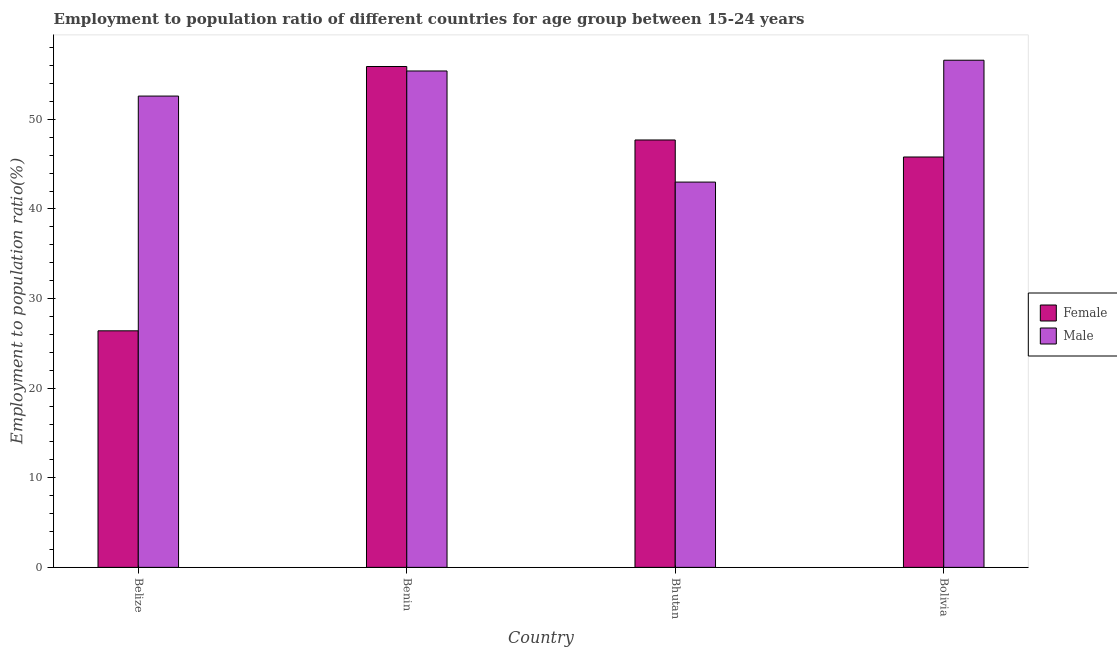How many groups of bars are there?
Your answer should be compact. 4. Are the number of bars per tick equal to the number of legend labels?
Offer a very short reply. Yes. Are the number of bars on each tick of the X-axis equal?
Offer a terse response. Yes. How many bars are there on the 1st tick from the left?
Your answer should be very brief. 2. How many bars are there on the 4th tick from the right?
Your response must be concise. 2. What is the label of the 3rd group of bars from the left?
Your response must be concise. Bhutan. In how many cases, is the number of bars for a given country not equal to the number of legend labels?
Your answer should be compact. 0. What is the employment to population ratio(female) in Bhutan?
Your response must be concise. 47.7. Across all countries, what is the maximum employment to population ratio(female)?
Your answer should be compact. 55.9. In which country was the employment to population ratio(female) maximum?
Your response must be concise. Benin. In which country was the employment to population ratio(female) minimum?
Offer a terse response. Belize. What is the total employment to population ratio(male) in the graph?
Your answer should be compact. 207.6. What is the difference between the employment to population ratio(male) in Belize and that in Benin?
Provide a short and direct response. -2.8. What is the difference between the employment to population ratio(male) in Bolivia and the employment to population ratio(female) in Benin?
Provide a short and direct response. 0.7. What is the average employment to population ratio(female) per country?
Provide a short and direct response. 43.95. What is the difference between the employment to population ratio(male) and employment to population ratio(female) in Bhutan?
Provide a short and direct response. -4.7. In how many countries, is the employment to population ratio(female) greater than 8 %?
Offer a very short reply. 4. What is the ratio of the employment to population ratio(female) in Belize to that in Bhutan?
Ensure brevity in your answer.  0.55. What is the difference between the highest and the second highest employment to population ratio(female)?
Make the answer very short. 8.2. What is the difference between the highest and the lowest employment to population ratio(female)?
Keep it short and to the point. 29.5. In how many countries, is the employment to population ratio(female) greater than the average employment to population ratio(female) taken over all countries?
Your answer should be compact. 3. Is the sum of the employment to population ratio(male) in Belize and Bolivia greater than the maximum employment to population ratio(female) across all countries?
Your answer should be very brief. Yes. What does the 2nd bar from the right in Bolivia represents?
Provide a succinct answer. Female. Are all the bars in the graph horizontal?
Offer a terse response. No. How many countries are there in the graph?
Make the answer very short. 4. What is the difference between two consecutive major ticks on the Y-axis?
Your answer should be very brief. 10. Are the values on the major ticks of Y-axis written in scientific E-notation?
Offer a terse response. No. What is the title of the graph?
Make the answer very short. Employment to population ratio of different countries for age group between 15-24 years. Does "Depositors" appear as one of the legend labels in the graph?
Give a very brief answer. No. What is the label or title of the X-axis?
Make the answer very short. Country. What is the Employment to population ratio(%) of Female in Belize?
Provide a short and direct response. 26.4. What is the Employment to population ratio(%) in Male in Belize?
Your response must be concise. 52.6. What is the Employment to population ratio(%) in Female in Benin?
Offer a terse response. 55.9. What is the Employment to population ratio(%) in Male in Benin?
Provide a short and direct response. 55.4. What is the Employment to population ratio(%) in Female in Bhutan?
Give a very brief answer. 47.7. What is the Employment to population ratio(%) in Male in Bhutan?
Your response must be concise. 43. What is the Employment to population ratio(%) in Female in Bolivia?
Keep it short and to the point. 45.8. What is the Employment to population ratio(%) in Male in Bolivia?
Give a very brief answer. 56.6. Across all countries, what is the maximum Employment to population ratio(%) in Female?
Offer a terse response. 55.9. Across all countries, what is the maximum Employment to population ratio(%) of Male?
Your response must be concise. 56.6. Across all countries, what is the minimum Employment to population ratio(%) in Female?
Ensure brevity in your answer.  26.4. Across all countries, what is the minimum Employment to population ratio(%) in Male?
Give a very brief answer. 43. What is the total Employment to population ratio(%) in Female in the graph?
Your response must be concise. 175.8. What is the total Employment to population ratio(%) of Male in the graph?
Offer a terse response. 207.6. What is the difference between the Employment to population ratio(%) in Female in Belize and that in Benin?
Ensure brevity in your answer.  -29.5. What is the difference between the Employment to population ratio(%) in Female in Belize and that in Bhutan?
Keep it short and to the point. -21.3. What is the difference between the Employment to population ratio(%) of Male in Belize and that in Bhutan?
Provide a succinct answer. 9.6. What is the difference between the Employment to population ratio(%) of Female in Belize and that in Bolivia?
Your answer should be compact. -19.4. What is the difference between the Employment to population ratio(%) of Female in Benin and that in Bhutan?
Your answer should be very brief. 8.2. What is the difference between the Employment to population ratio(%) of Male in Benin and that in Bolivia?
Your answer should be compact. -1.2. What is the difference between the Employment to population ratio(%) in Female in Belize and the Employment to population ratio(%) in Male in Benin?
Your answer should be compact. -29. What is the difference between the Employment to population ratio(%) in Female in Belize and the Employment to population ratio(%) in Male in Bhutan?
Your answer should be compact. -16.6. What is the difference between the Employment to population ratio(%) in Female in Belize and the Employment to population ratio(%) in Male in Bolivia?
Keep it short and to the point. -30.2. What is the difference between the Employment to population ratio(%) of Female in Benin and the Employment to population ratio(%) of Male in Bhutan?
Make the answer very short. 12.9. What is the difference between the Employment to population ratio(%) in Female in Benin and the Employment to population ratio(%) in Male in Bolivia?
Keep it short and to the point. -0.7. What is the difference between the Employment to population ratio(%) in Female in Bhutan and the Employment to population ratio(%) in Male in Bolivia?
Your response must be concise. -8.9. What is the average Employment to population ratio(%) in Female per country?
Give a very brief answer. 43.95. What is the average Employment to population ratio(%) of Male per country?
Offer a terse response. 51.9. What is the difference between the Employment to population ratio(%) of Female and Employment to population ratio(%) of Male in Belize?
Your response must be concise. -26.2. What is the difference between the Employment to population ratio(%) in Female and Employment to population ratio(%) in Male in Benin?
Your answer should be compact. 0.5. What is the difference between the Employment to population ratio(%) of Female and Employment to population ratio(%) of Male in Bolivia?
Your response must be concise. -10.8. What is the ratio of the Employment to population ratio(%) in Female in Belize to that in Benin?
Ensure brevity in your answer.  0.47. What is the ratio of the Employment to population ratio(%) of Male in Belize to that in Benin?
Provide a short and direct response. 0.95. What is the ratio of the Employment to population ratio(%) of Female in Belize to that in Bhutan?
Ensure brevity in your answer.  0.55. What is the ratio of the Employment to population ratio(%) in Male in Belize to that in Bhutan?
Offer a very short reply. 1.22. What is the ratio of the Employment to population ratio(%) of Female in Belize to that in Bolivia?
Make the answer very short. 0.58. What is the ratio of the Employment to population ratio(%) of Male in Belize to that in Bolivia?
Offer a very short reply. 0.93. What is the ratio of the Employment to population ratio(%) in Female in Benin to that in Bhutan?
Keep it short and to the point. 1.17. What is the ratio of the Employment to population ratio(%) in Male in Benin to that in Bhutan?
Offer a very short reply. 1.29. What is the ratio of the Employment to population ratio(%) in Female in Benin to that in Bolivia?
Provide a succinct answer. 1.22. What is the ratio of the Employment to population ratio(%) in Male in Benin to that in Bolivia?
Make the answer very short. 0.98. What is the ratio of the Employment to population ratio(%) in Female in Bhutan to that in Bolivia?
Offer a very short reply. 1.04. What is the ratio of the Employment to population ratio(%) in Male in Bhutan to that in Bolivia?
Offer a terse response. 0.76. What is the difference between the highest and the second highest Employment to population ratio(%) in Female?
Offer a very short reply. 8.2. What is the difference between the highest and the lowest Employment to population ratio(%) in Female?
Your response must be concise. 29.5. 